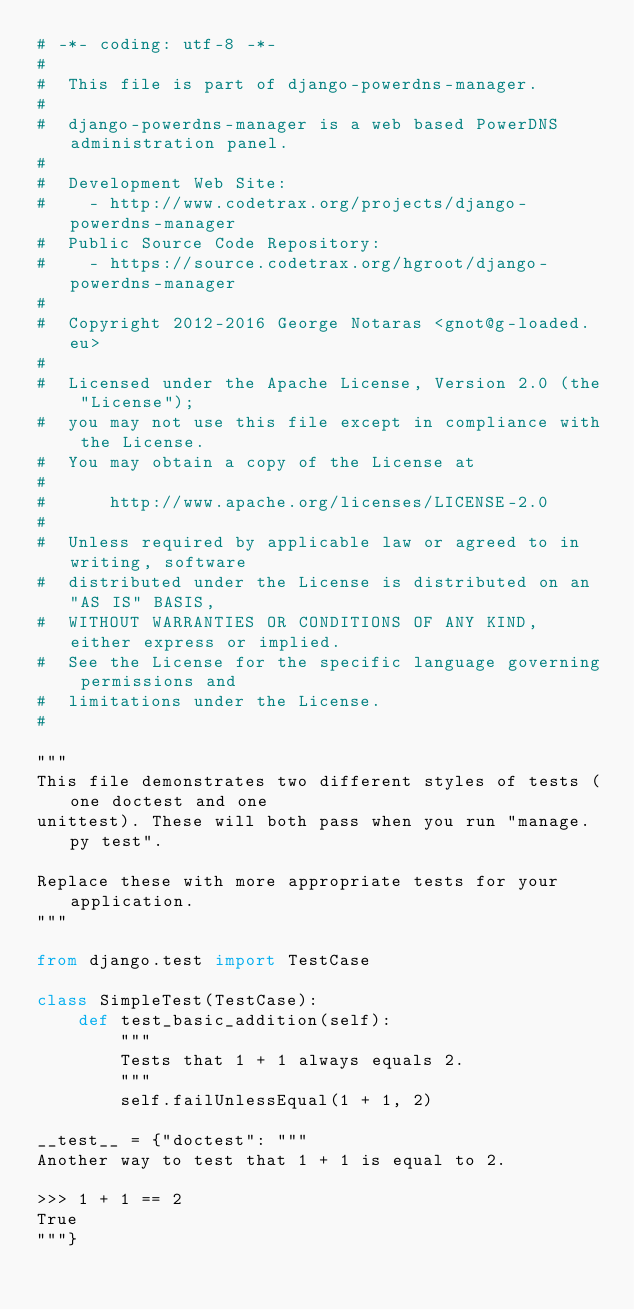Convert code to text. <code><loc_0><loc_0><loc_500><loc_500><_Python_># -*- coding: utf-8 -*-
#
#  This file is part of django-powerdns-manager.
#
#  django-powerdns-manager is a web based PowerDNS administration panel.
#
#  Development Web Site:
#    - http://www.codetrax.org/projects/django-powerdns-manager
#  Public Source Code Repository:
#    - https://source.codetrax.org/hgroot/django-powerdns-manager
#
#  Copyright 2012-2016 George Notaras <gnot@g-loaded.eu>
#
#  Licensed under the Apache License, Version 2.0 (the "License");
#  you may not use this file except in compliance with the License.
#  You may obtain a copy of the License at
#
#      http://www.apache.org/licenses/LICENSE-2.0
#
#  Unless required by applicable law or agreed to in writing, software
#  distributed under the License is distributed on an "AS IS" BASIS,
#  WITHOUT WARRANTIES OR CONDITIONS OF ANY KIND, either express or implied.
#  See the License for the specific language governing permissions and
#  limitations under the License.
#

"""
This file demonstrates two different styles of tests (one doctest and one
unittest). These will both pass when you run "manage.py test".

Replace these with more appropriate tests for your application.
"""

from django.test import TestCase

class SimpleTest(TestCase):
    def test_basic_addition(self):
        """
        Tests that 1 + 1 always equals 2.
        """
        self.failUnlessEqual(1 + 1, 2)

__test__ = {"doctest": """
Another way to test that 1 + 1 is equal to 2.

>>> 1 + 1 == 2
True
"""}

</code> 